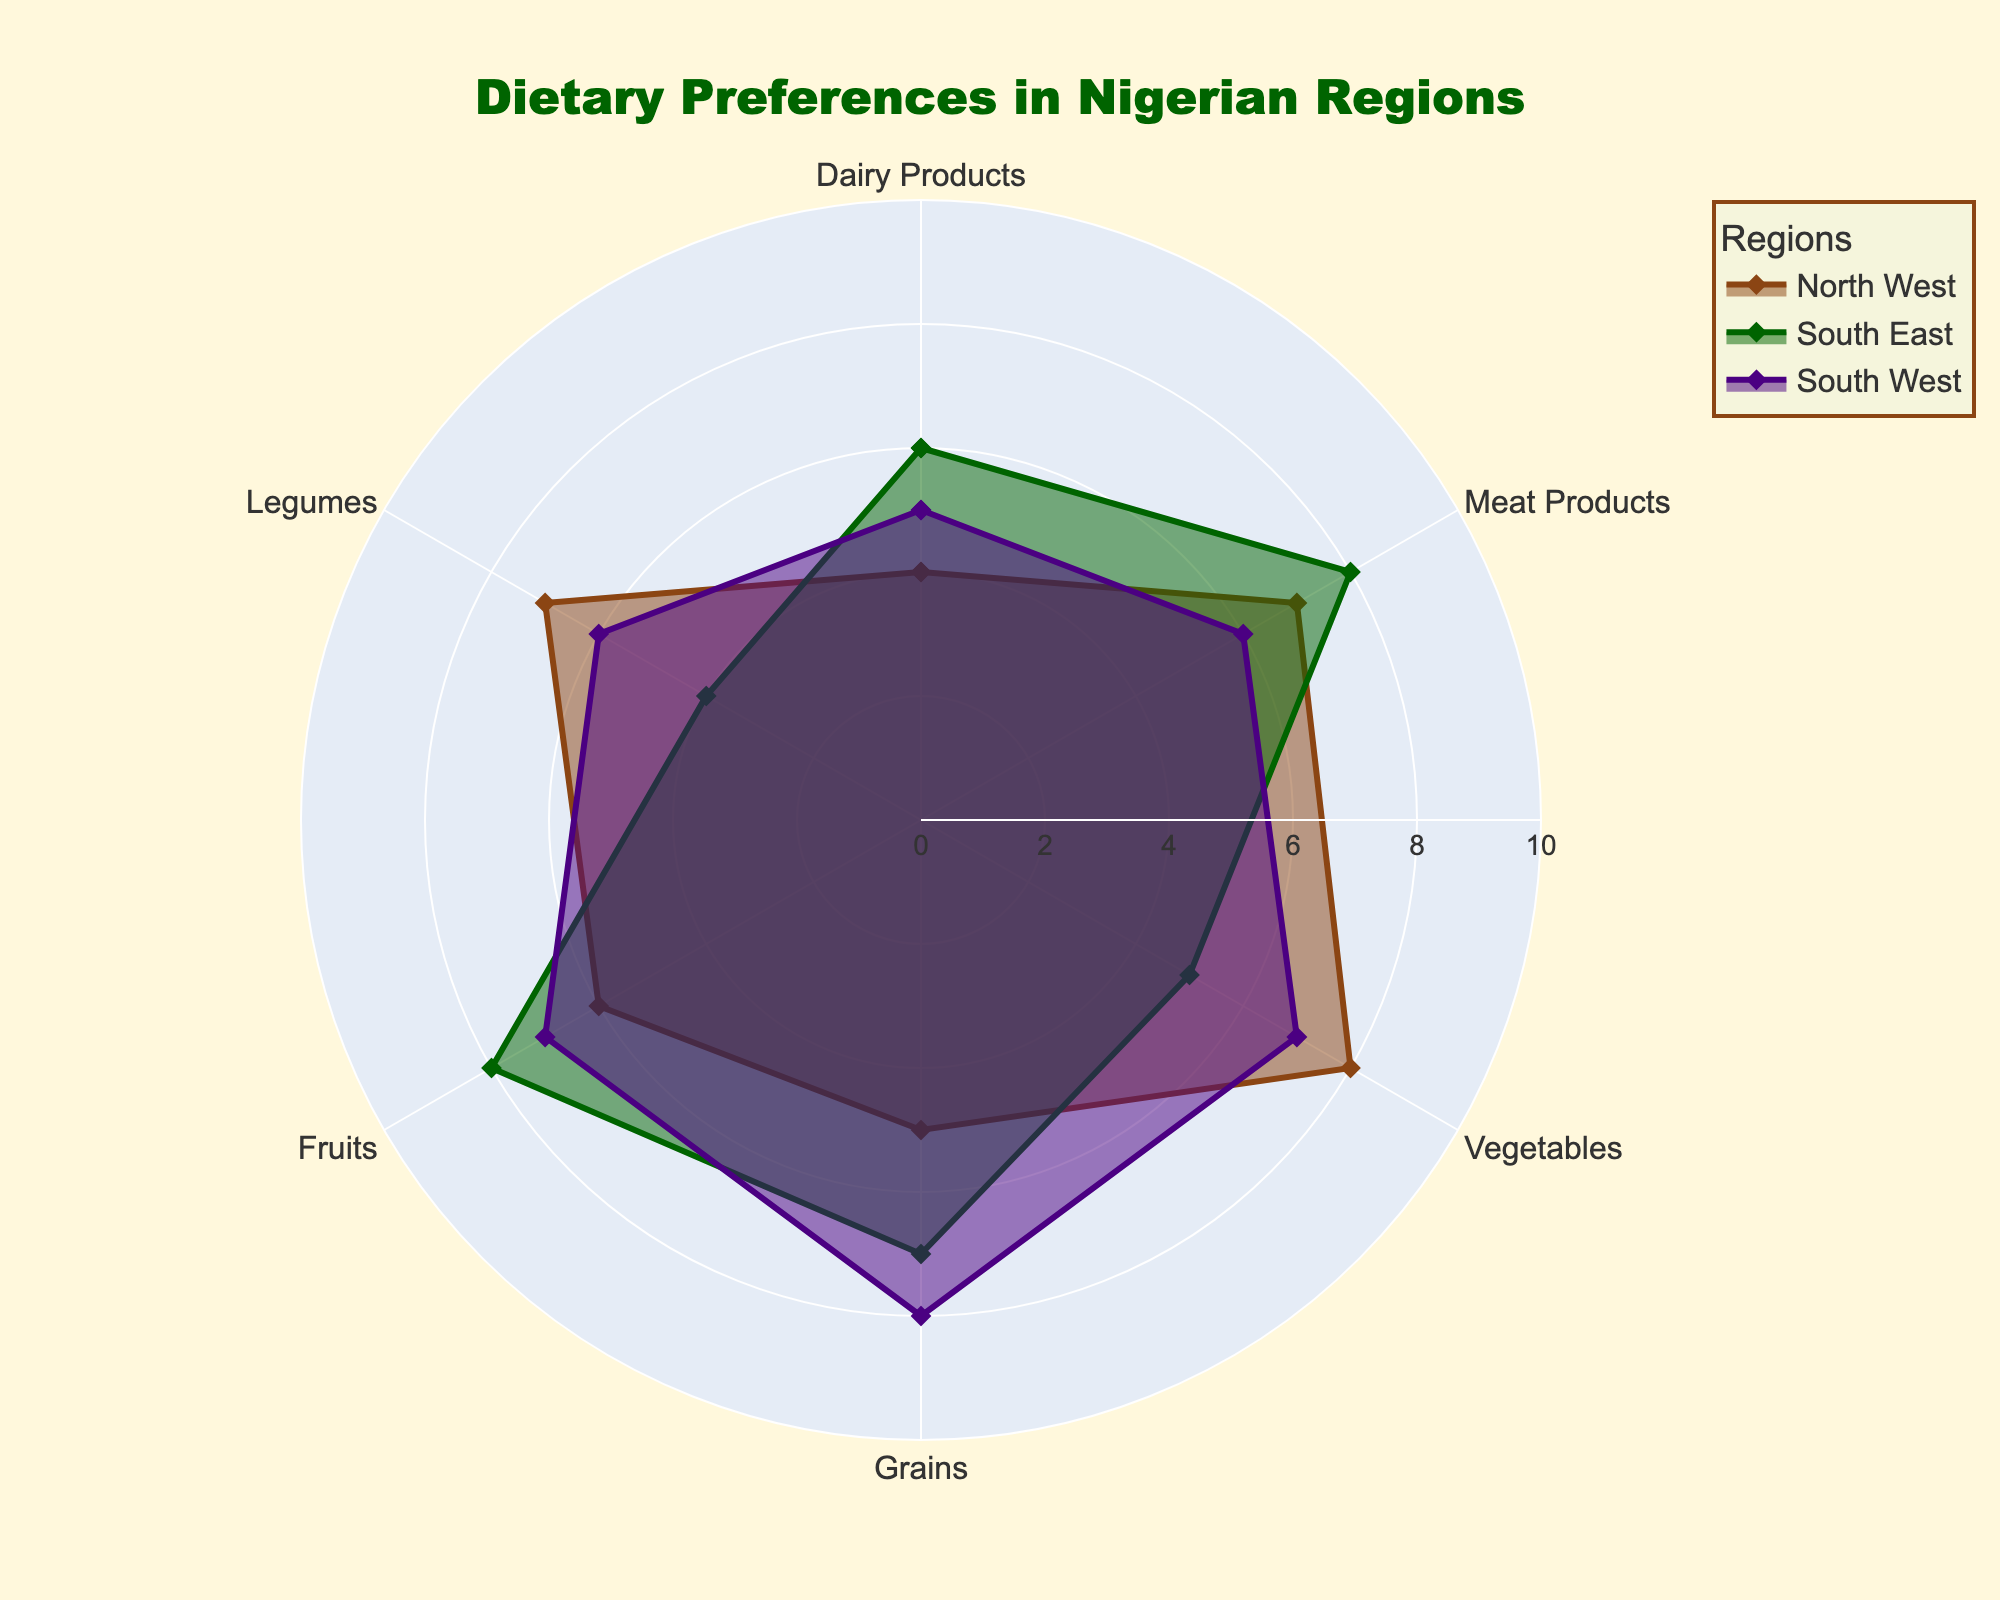What is the title of the radar chart? The title is usually located at the top of the chart and describes the content of the figure. In this case, you can read it from the figure directly.
Answer: Dietary Preferences in Nigerian Regions How many regions are compared in this radar chart? By looking at the different colored areas within the radar chart, one can see that there are three distinct regions being compared. These are North West, South East, and South West.
Answer: 3 Which region prefers Meat Products the most? By examining the lines associated with the Meat Products axis, one can identify which region has the highest value. In this case, the South East region has the highest value for Meat Products.
Answer: South East What is the range for the radial axis in the radar chart? The radial axis range can be determined by looking at the radial lines and their labels extending from the center to the outer edge. It starts from 0 and goes up to 10.
Answer: 0 to 10 Which region has the lowest preference for Legumes? Look at the values plotted on the Legumes axis for each region. The South East has the lowest value for Legumes, indicated by the point closest to the center.
Answer: South East On average, which region has the highest preference for dietary categories? Calculate the averages of the plotted values across all the categories for each region (i.e., sum up all the values for a region and divide by the number of categories). Then compare these averages. For the North West (4+7+8+5+6+7)/6=6.17, for South East (6+8+5+7+8+4)/6=6.33, for South West (5+6+7+8+7+6)/6=6.5. The region with the highest average is South West.
Answer: South West Which three dietary categories does the North West region prefer the most? Observe the values for each dietary category for the North West region and select the three highest values, which are Vegetables (8), Legumes (7), and Meat Products (7).
Answer: Vegetables, Legumes, Meat Products Compare the preference for Fruits between North West and South East regions. Which region has a higher preference? Check the Fruits axis to see the corresponding values for North West and South East regions. The values are 6 for North West and 8 for South East. South East has a higher preference.
Answer: South East What is the difference in preference for Grains between South East and South West regions? Look at the values for Grains for both South East and South West. Subtract the South West's value (8) from South East's value (7). The difference is 1 in favor of South West.
Answer: 1 